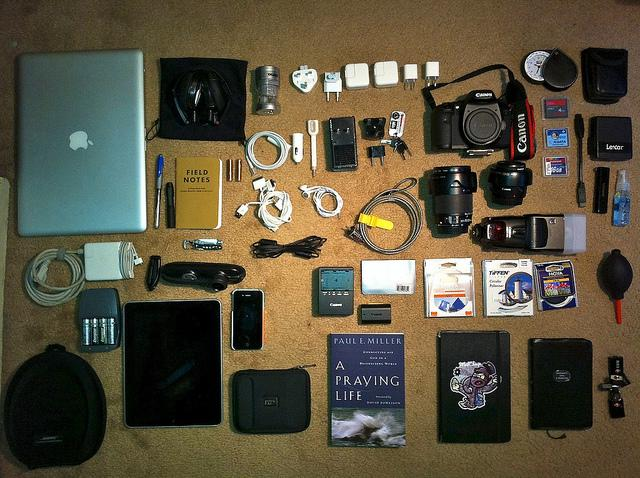The book was based on a series of what by the author?

Choices:
A) songs
B) seminars
C) dreams
D) sermons seminars 